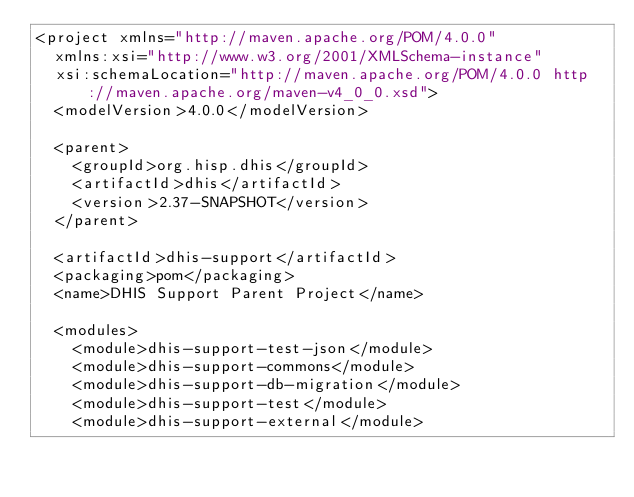<code> <loc_0><loc_0><loc_500><loc_500><_XML_><project xmlns="http://maven.apache.org/POM/4.0.0"
  xmlns:xsi="http://www.w3.org/2001/XMLSchema-instance"
  xsi:schemaLocation="http://maven.apache.org/POM/4.0.0 http://maven.apache.org/maven-v4_0_0.xsd">
  <modelVersion>4.0.0</modelVersion>

  <parent>
    <groupId>org.hisp.dhis</groupId>
    <artifactId>dhis</artifactId>
    <version>2.37-SNAPSHOT</version>
  </parent>

  <artifactId>dhis-support</artifactId>
  <packaging>pom</packaging>
  <name>DHIS Support Parent Project</name>

  <modules>
    <module>dhis-support-test-json</module>
    <module>dhis-support-commons</module>
    <module>dhis-support-db-migration</module>
    <module>dhis-support-test</module>
    <module>dhis-support-external</module></code> 